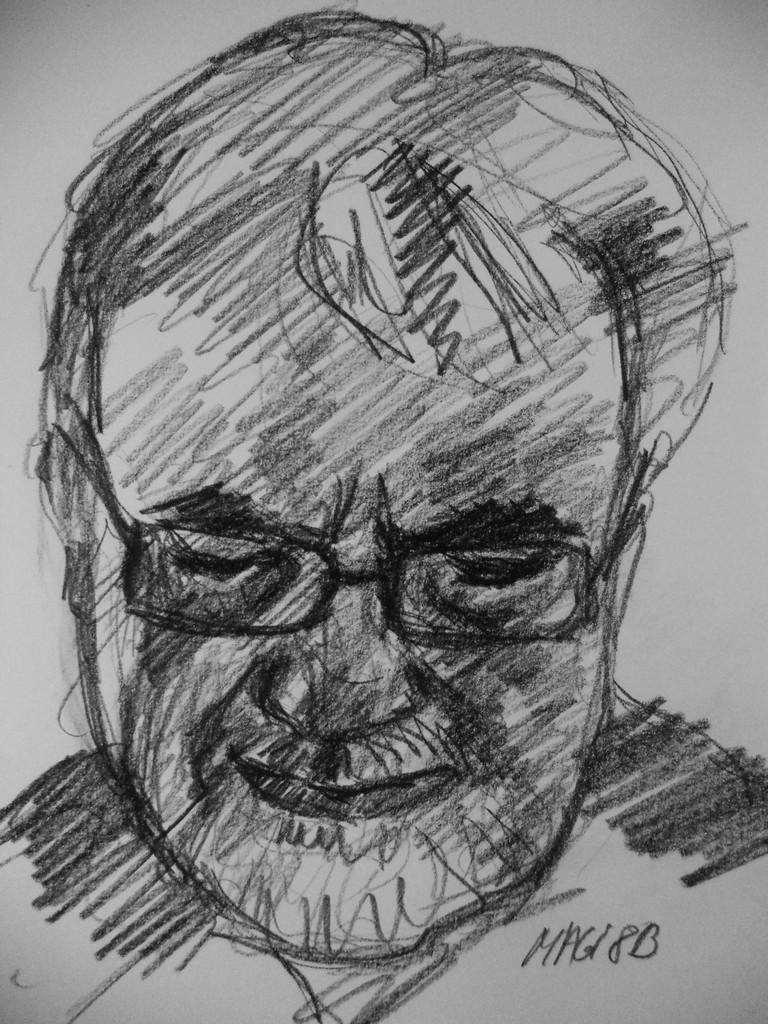What type of artwork is depicted in the image? There is a sketch painting in the image. What subject is featured in the sketch painting? The sketch painting is of a man. What color scheme is used in the sketch painting? The color of the painting is black and white. How does the man in the sketch painting express his disgust towards the roof? There is no roof or expression of disgust present in the image; it only features a black and white sketch painting of a man. 